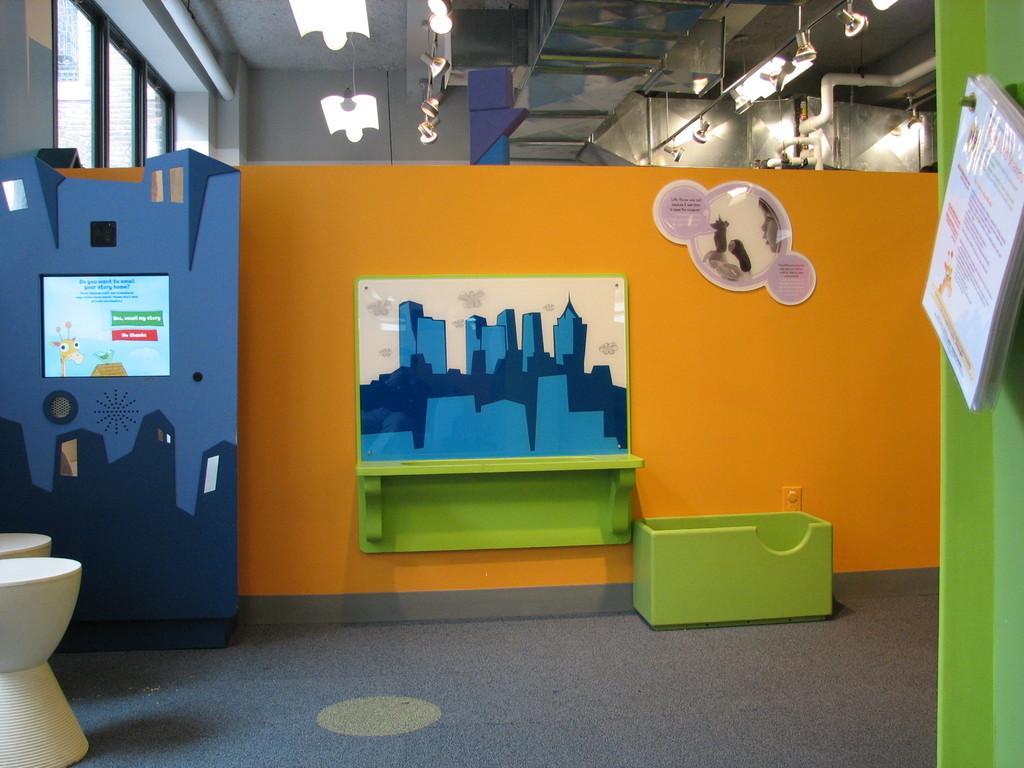Describe this image in one or two sentences. This picture is clicked inside. On the left we can see the stools and a green color object placed on the ground and we can see the pictures of buildings on the wall and there are some papers hanging on the wall. At the top there is a roof and we can see the ceiling lights, metal rods and the window. 